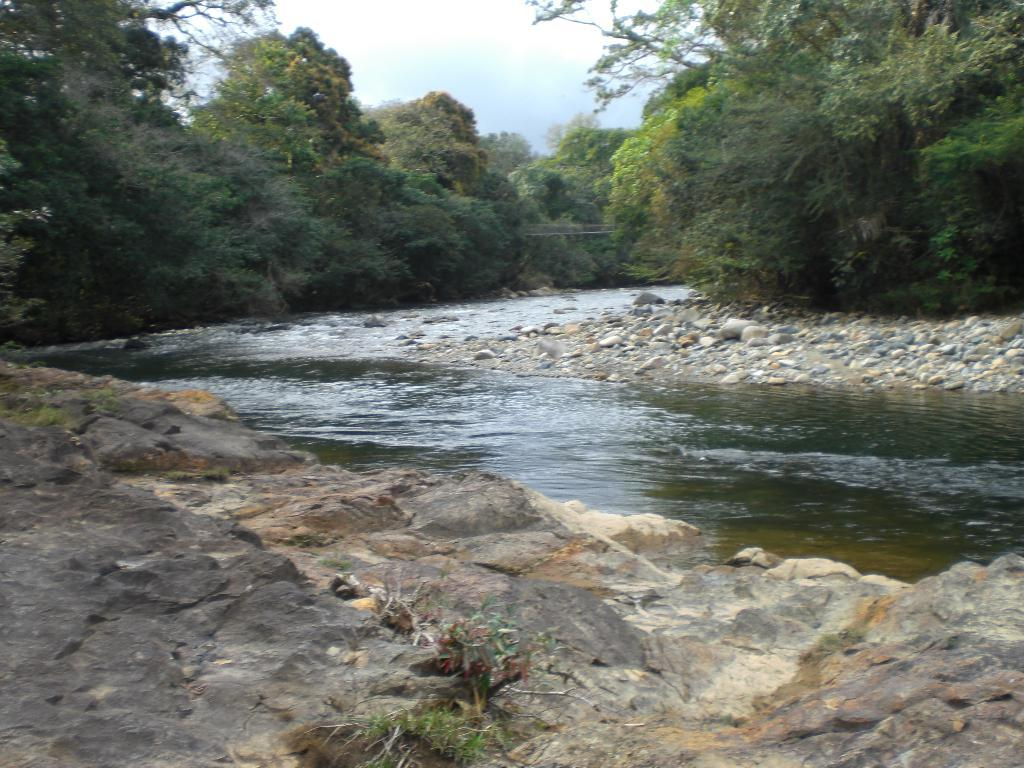What type of natural elements can be seen in the image? There are many trees and stones in the image. Can you describe the rock in the image? Yes, there is a rock in the image. What else is visible in the image besides trees and stones? There is water and the sky visible in the image. What type of pin can be seen holding the bushes together in the image? There is no pin or bushes present in the image. What kind of pet can be seen playing near the water in the image? There is no pet visible in the image. 